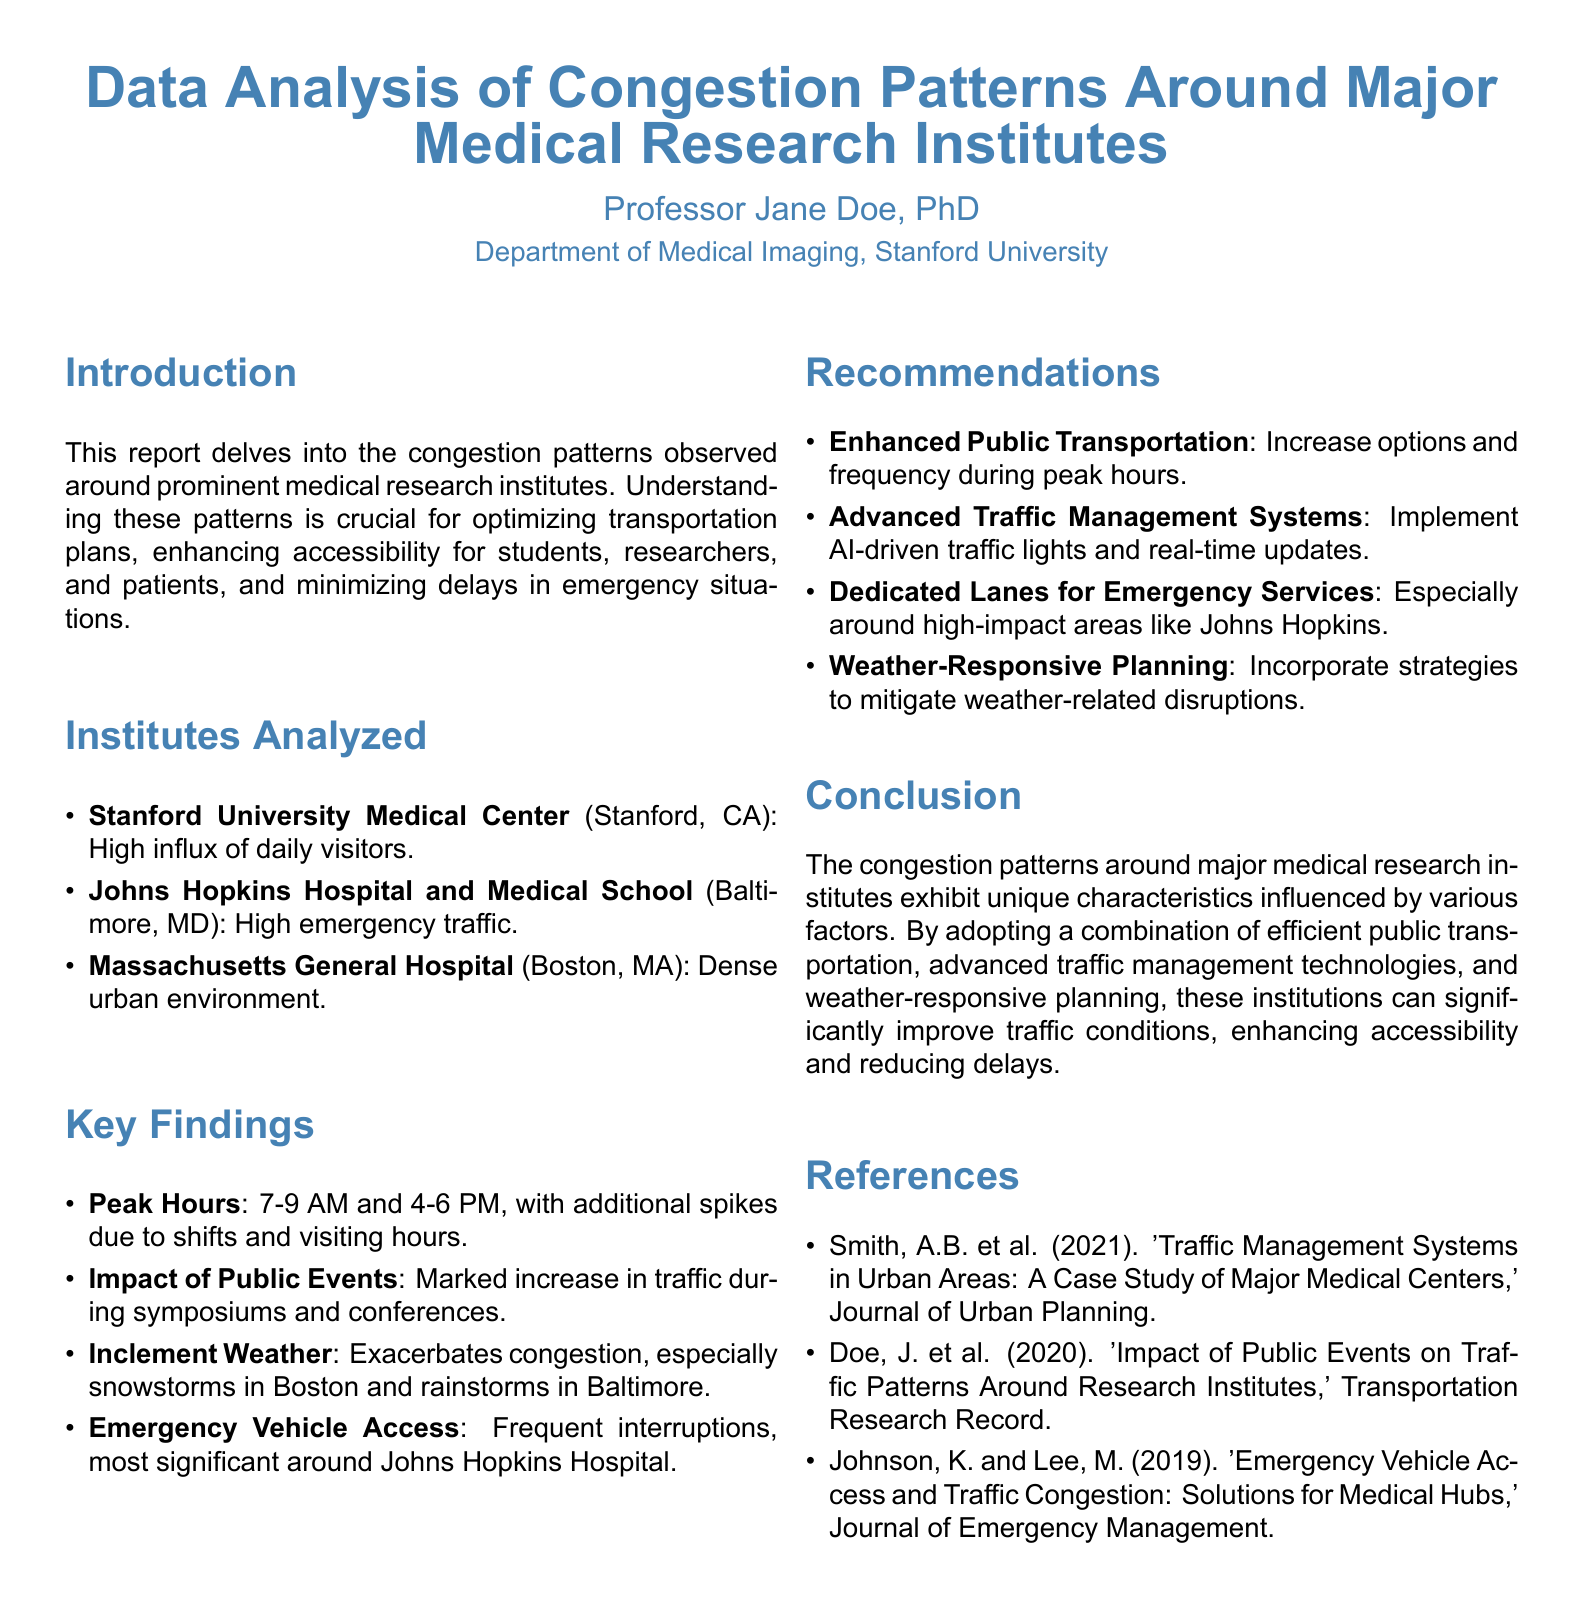What are the names of the institutes analyzed? The names of the institutes are listed in the "Institutes Analyzed" section: Stanford University Medical Center, Johns Hopkins Hospital and Medical School, and Massachusetts General Hospital.
Answer: Stanford University Medical Center, Johns Hopkins Hospital and Medical School, Massachusetts General Hospital What is the peak hour range for congestion? The peak hours are mentioned in the "Key Findings" section, specifically as the times when traffic is highest.
Answer: 7-9 AM and 4-6 PM What is one recommendation provided for traffic management? The recommendations section outlines various strategies, looking for options for traffic management.
Answer: Enhanced Public Transportation Which institute has a significant emergency vehicle access issue? The report identifies the institute that frequently interrupts traffic due to emergency vehicles in the "Key Findings" section.
Answer: Johns Hopkins Hospital What weather condition notably worsens congestion in Boston? The report highlights a specific weather-related issue in the "Key Findings," particularly in Boston.
Answer: Snowstorms 